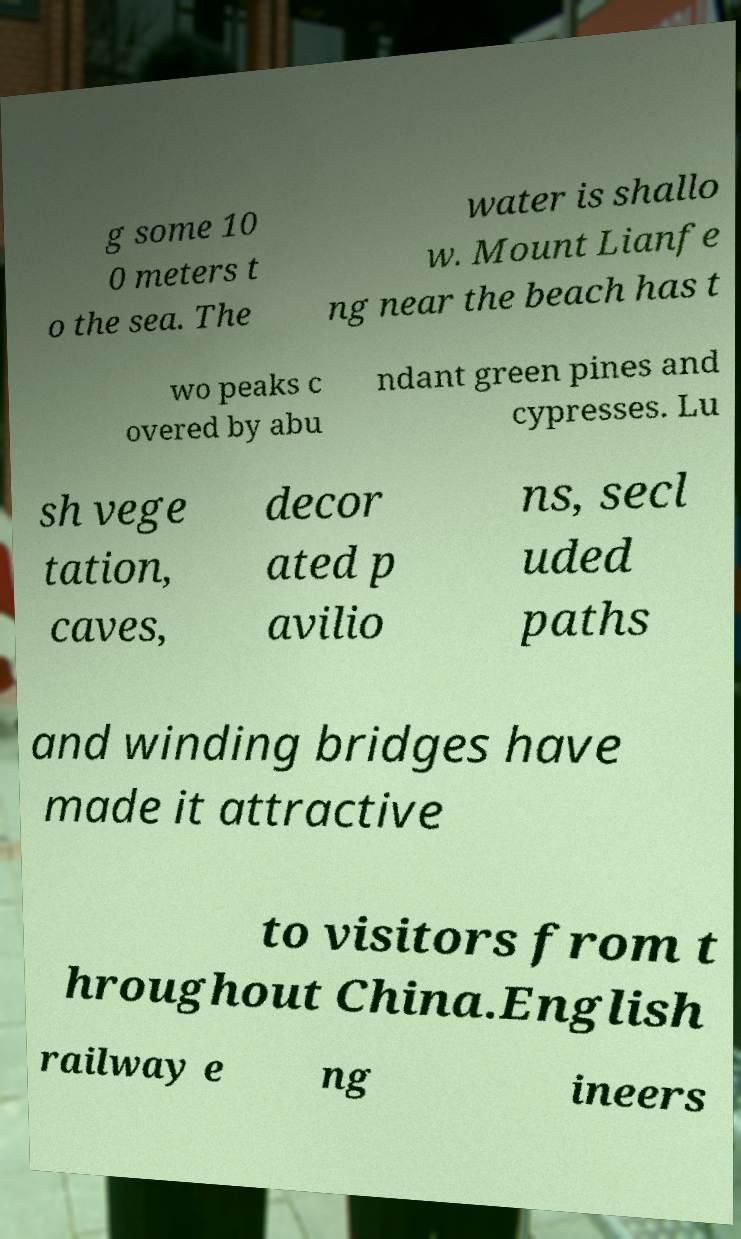Can you accurately transcribe the text from the provided image for me? g some 10 0 meters t o the sea. The water is shallo w. Mount Lianfe ng near the beach has t wo peaks c overed by abu ndant green pines and cypresses. Lu sh vege tation, caves, decor ated p avilio ns, secl uded paths and winding bridges have made it attractive to visitors from t hroughout China.English railway e ng ineers 